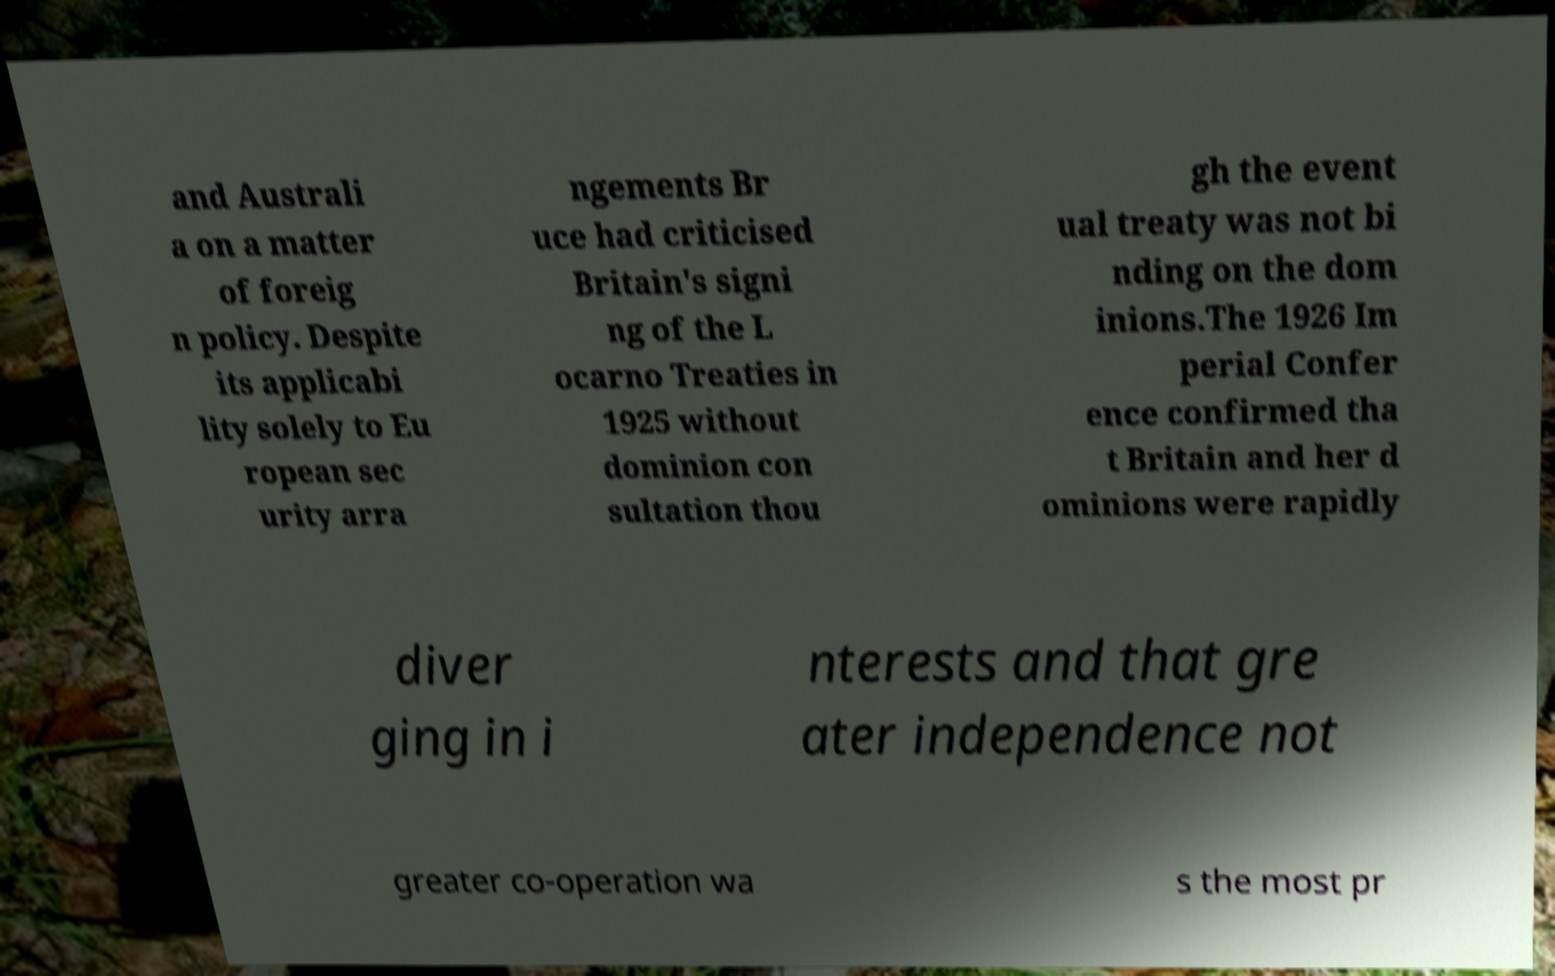Please identify and transcribe the text found in this image. and Australi a on a matter of foreig n policy. Despite its applicabi lity solely to Eu ropean sec urity arra ngements Br uce had criticised Britain's signi ng of the L ocarno Treaties in 1925 without dominion con sultation thou gh the event ual treaty was not bi nding on the dom inions.The 1926 Im perial Confer ence confirmed tha t Britain and her d ominions were rapidly diver ging in i nterests and that gre ater independence not greater co-operation wa s the most pr 